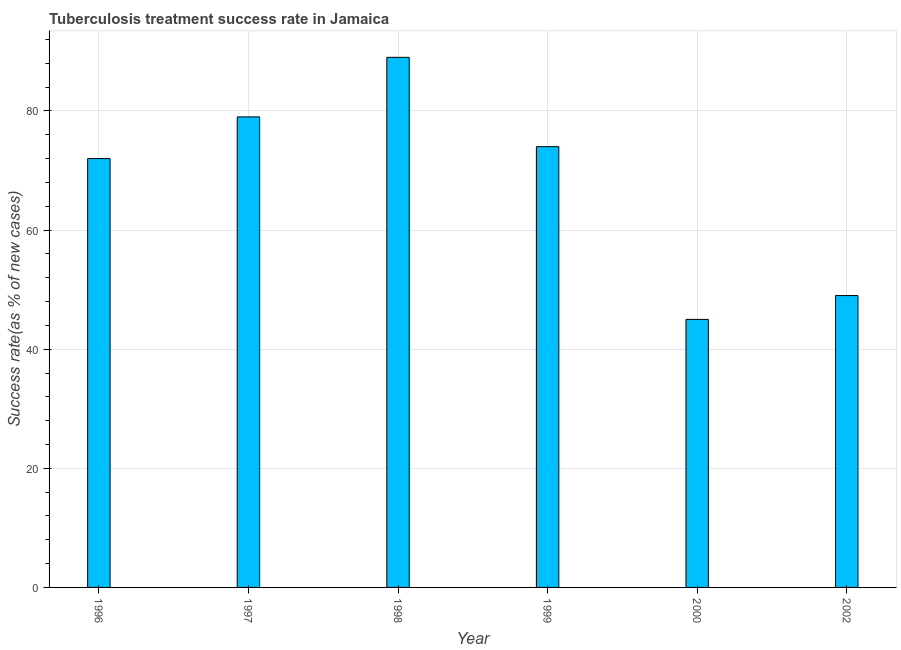Does the graph contain any zero values?
Your answer should be compact. No. Does the graph contain grids?
Make the answer very short. Yes. What is the title of the graph?
Offer a very short reply. Tuberculosis treatment success rate in Jamaica. What is the label or title of the Y-axis?
Make the answer very short. Success rate(as % of new cases). Across all years, what is the maximum tuberculosis treatment success rate?
Keep it short and to the point. 89. In which year was the tuberculosis treatment success rate maximum?
Make the answer very short. 1998. In which year was the tuberculosis treatment success rate minimum?
Provide a succinct answer. 2000. What is the sum of the tuberculosis treatment success rate?
Provide a short and direct response. 408. What is the average tuberculosis treatment success rate per year?
Ensure brevity in your answer.  68. What is the median tuberculosis treatment success rate?
Offer a terse response. 73. Do a majority of the years between 1999 and 2000 (inclusive) have tuberculosis treatment success rate greater than 4 %?
Keep it short and to the point. Yes. What is the ratio of the tuberculosis treatment success rate in 1996 to that in 1998?
Give a very brief answer. 0.81. Is the tuberculosis treatment success rate in 1996 less than that in 1999?
Your answer should be very brief. Yes. What is the difference between the highest and the second highest tuberculosis treatment success rate?
Make the answer very short. 10. Is the sum of the tuberculosis treatment success rate in 1998 and 2002 greater than the maximum tuberculosis treatment success rate across all years?
Your answer should be very brief. Yes. In how many years, is the tuberculosis treatment success rate greater than the average tuberculosis treatment success rate taken over all years?
Your answer should be compact. 4. What is the difference between two consecutive major ticks on the Y-axis?
Offer a terse response. 20. What is the Success rate(as % of new cases) of 1997?
Ensure brevity in your answer.  79. What is the Success rate(as % of new cases) of 1998?
Offer a very short reply. 89. What is the difference between the Success rate(as % of new cases) in 1996 and 1998?
Make the answer very short. -17. What is the difference between the Success rate(as % of new cases) in 1996 and 1999?
Offer a terse response. -2. What is the difference between the Success rate(as % of new cases) in 1996 and 2000?
Offer a terse response. 27. What is the difference between the Success rate(as % of new cases) in 1997 and 2000?
Ensure brevity in your answer.  34. What is the difference between the Success rate(as % of new cases) in 1998 and 2000?
Provide a short and direct response. 44. What is the difference between the Success rate(as % of new cases) in 1998 and 2002?
Your answer should be compact. 40. What is the difference between the Success rate(as % of new cases) in 1999 and 2000?
Your answer should be very brief. 29. What is the difference between the Success rate(as % of new cases) in 2000 and 2002?
Make the answer very short. -4. What is the ratio of the Success rate(as % of new cases) in 1996 to that in 1997?
Provide a succinct answer. 0.91. What is the ratio of the Success rate(as % of new cases) in 1996 to that in 1998?
Provide a succinct answer. 0.81. What is the ratio of the Success rate(as % of new cases) in 1996 to that in 1999?
Provide a short and direct response. 0.97. What is the ratio of the Success rate(as % of new cases) in 1996 to that in 2000?
Offer a very short reply. 1.6. What is the ratio of the Success rate(as % of new cases) in 1996 to that in 2002?
Offer a terse response. 1.47. What is the ratio of the Success rate(as % of new cases) in 1997 to that in 1998?
Your response must be concise. 0.89. What is the ratio of the Success rate(as % of new cases) in 1997 to that in 1999?
Give a very brief answer. 1.07. What is the ratio of the Success rate(as % of new cases) in 1997 to that in 2000?
Give a very brief answer. 1.76. What is the ratio of the Success rate(as % of new cases) in 1997 to that in 2002?
Provide a succinct answer. 1.61. What is the ratio of the Success rate(as % of new cases) in 1998 to that in 1999?
Your response must be concise. 1.2. What is the ratio of the Success rate(as % of new cases) in 1998 to that in 2000?
Make the answer very short. 1.98. What is the ratio of the Success rate(as % of new cases) in 1998 to that in 2002?
Ensure brevity in your answer.  1.82. What is the ratio of the Success rate(as % of new cases) in 1999 to that in 2000?
Offer a terse response. 1.64. What is the ratio of the Success rate(as % of new cases) in 1999 to that in 2002?
Your answer should be compact. 1.51. What is the ratio of the Success rate(as % of new cases) in 2000 to that in 2002?
Your answer should be very brief. 0.92. 